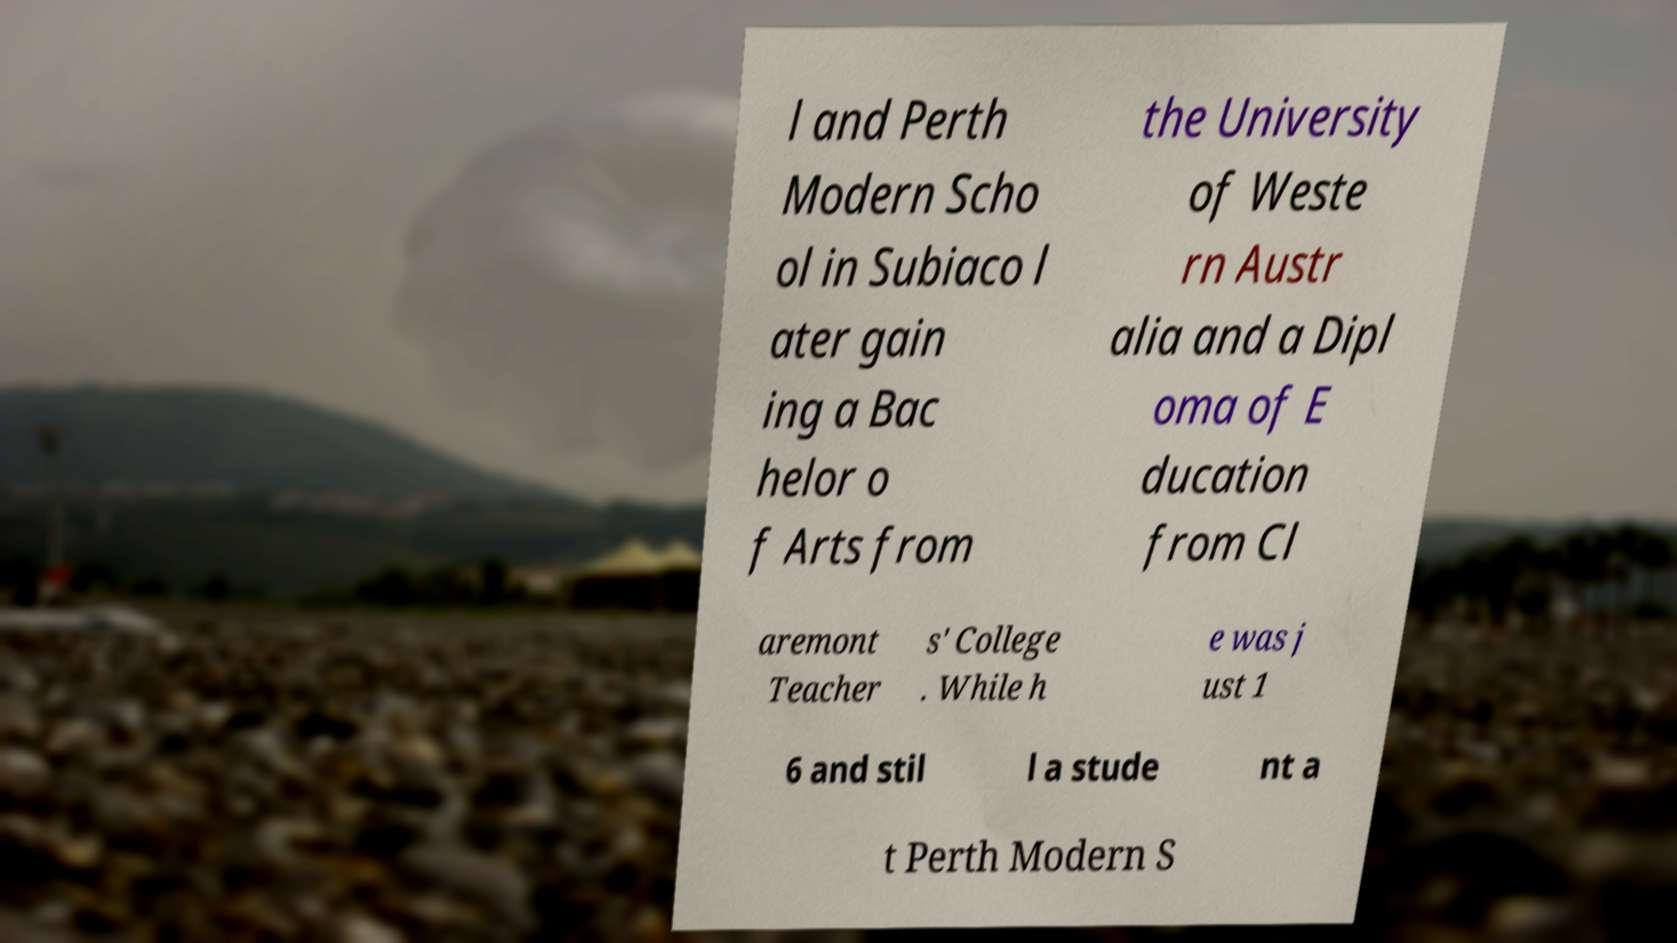For documentation purposes, I need the text within this image transcribed. Could you provide that? l and Perth Modern Scho ol in Subiaco l ater gain ing a Bac helor o f Arts from the University of Weste rn Austr alia and a Dipl oma of E ducation from Cl aremont Teacher s' College . While h e was j ust 1 6 and stil l a stude nt a t Perth Modern S 